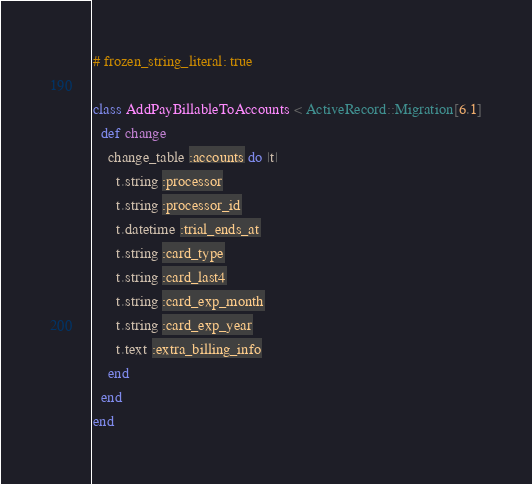<code> <loc_0><loc_0><loc_500><loc_500><_Ruby_># frozen_string_literal: true

class AddPayBillableToAccounts < ActiveRecord::Migration[6.1]
  def change
    change_table :accounts do |t|
      t.string :processor
      t.string :processor_id
      t.datetime :trial_ends_at
      t.string :card_type
      t.string :card_last4
      t.string :card_exp_month
      t.string :card_exp_year
      t.text :extra_billing_info
    end
  end
end
</code> 